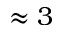Convert formula to latex. <formula><loc_0><loc_0><loc_500><loc_500>\approx 3</formula> 